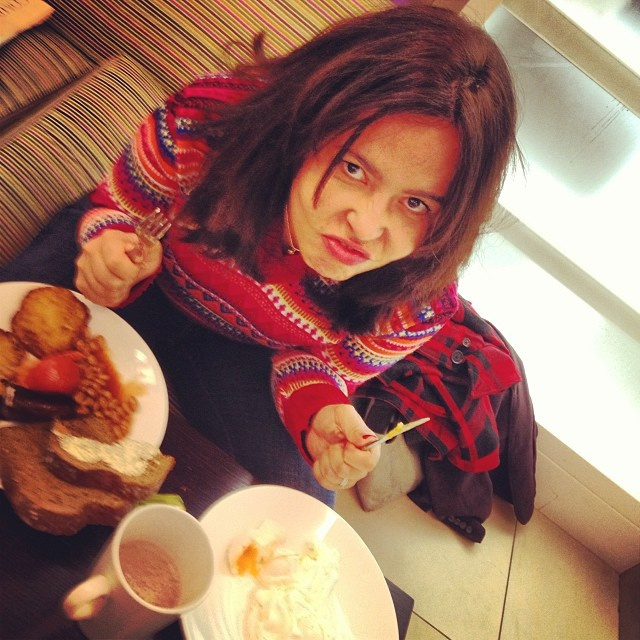Describe the objects in this image and their specific colors. I can see people in orange, black, maroon, brown, and tan tones, dining table in orange, khaki, black, maroon, and tan tones, couch in orange, maroon, tan, and brown tones, cup in orange, tan, red, and maroon tones, and cake in orange, brown, red, and maroon tones in this image. 